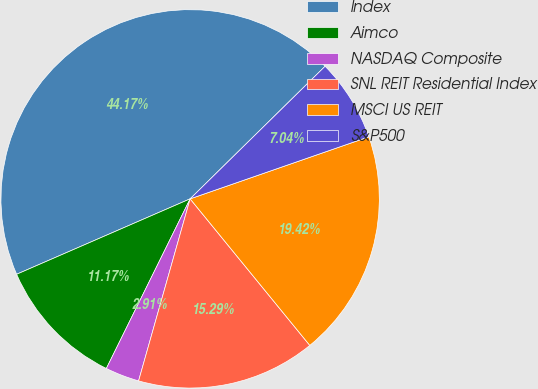Convert chart. <chart><loc_0><loc_0><loc_500><loc_500><pie_chart><fcel>Index<fcel>Aimco<fcel>NASDAQ Composite<fcel>SNL REIT Residential Index<fcel>MSCI US REIT<fcel>S&P500<nl><fcel>44.17%<fcel>11.17%<fcel>2.91%<fcel>15.29%<fcel>19.42%<fcel>7.04%<nl></chart> 